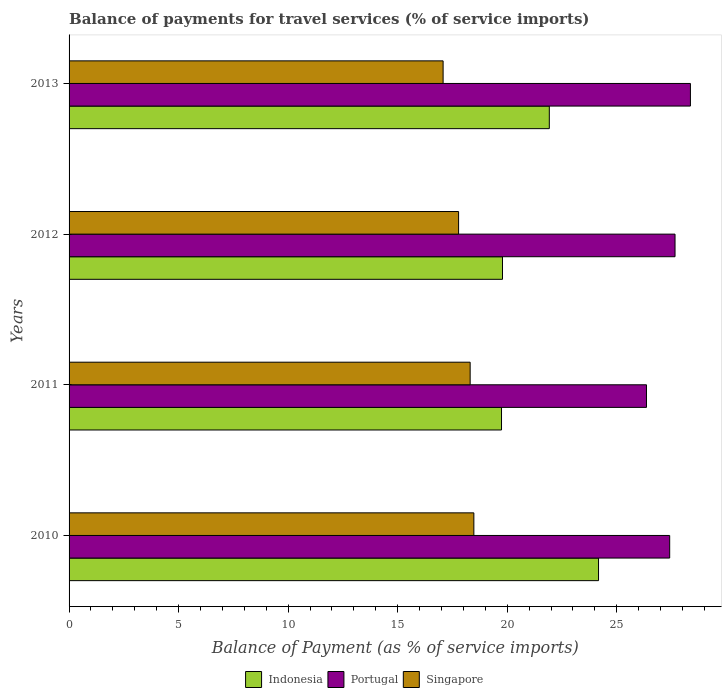How many different coloured bars are there?
Your answer should be compact. 3. Are the number of bars per tick equal to the number of legend labels?
Offer a terse response. Yes. Are the number of bars on each tick of the Y-axis equal?
Offer a terse response. Yes. In how many cases, is the number of bars for a given year not equal to the number of legend labels?
Offer a terse response. 0. What is the balance of payments for travel services in Singapore in 2012?
Provide a succinct answer. 17.78. Across all years, what is the maximum balance of payments for travel services in Portugal?
Give a very brief answer. 28.36. Across all years, what is the minimum balance of payments for travel services in Singapore?
Your answer should be very brief. 17.07. In which year was the balance of payments for travel services in Indonesia maximum?
Offer a very short reply. 2010. What is the total balance of payments for travel services in Indonesia in the graph?
Give a very brief answer. 85.61. What is the difference between the balance of payments for travel services in Indonesia in 2010 and that in 2013?
Provide a succinct answer. 2.25. What is the difference between the balance of payments for travel services in Singapore in 2010 and the balance of payments for travel services in Portugal in 2011?
Give a very brief answer. -7.88. What is the average balance of payments for travel services in Indonesia per year?
Your answer should be very brief. 21.4. In the year 2010, what is the difference between the balance of payments for travel services in Singapore and balance of payments for travel services in Portugal?
Offer a terse response. -8.94. In how many years, is the balance of payments for travel services in Indonesia greater than 1 %?
Offer a terse response. 4. What is the ratio of the balance of payments for travel services in Singapore in 2011 to that in 2012?
Make the answer very short. 1.03. What is the difference between the highest and the second highest balance of payments for travel services in Indonesia?
Keep it short and to the point. 2.25. What is the difference between the highest and the lowest balance of payments for travel services in Indonesia?
Your answer should be very brief. 4.43. What does the 3rd bar from the top in 2010 represents?
Offer a very short reply. Indonesia. Are all the bars in the graph horizontal?
Make the answer very short. Yes. How many years are there in the graph?
Offer a very short reply. 4. What is the difference between two consecutive major ticks on the X-axis?
Give a very brief answer. 5. Are the values on the major ticks of X-axis written in scientific E-notation?
Provide a short and direct response. No. Where does the legend appear in the graph?
Your answer should be very brief. Bottom center. How are the legend labels stacked?
Your answer should be very brief. Horizontal. What is the title of the graph?
Give a very brief answer. Balance of payments for travel services (% of service imports). What is the label or title of the X-axis?
Provide a short and direct response. Balance of Payment (as % of service imports). What is the Balance of Payment (as % of service imports) in Indonesia in 2010?
Offer a terse response. 24.17. What is the Balance of Payment (as % of service imports) in Portugal in 2010?
Provide a succinct answer. 27.41. What is the Balance of Payment (as % of service imports) in Singapore in 2010?
Your answer should be very brief. 18.48. What is the Balance of Payment (as % of service imports) of Indonesia in 2011?
Make the answer very short. 19.74. What is the Balance of Payment (as % of service imports) of Portugal in 2011?
Offer a terse response. 26.35. What is the Balance of Payment (as % of service imports) of Singapore in 2011?
Your answer should be compact. 18.31. What is the Balance of Payment (as % of service imports) of Indonesia in 2012?
Offer a very short reply. 19.78. What is the Balance of Payment (as % of service imports) of Portugal in 2012?
Offer a very short reply. 27.66. What is the Balance of Payment (as % of service imports) in Singapore in 2012?
Make the answer very short. 17.78. What is the Balance of Payment (as % of service imports) of Indonesia in 2013?
Give a very brief answer. 21.92. What is the Balance of Payment (as % of service imports) in Portugal in 2013?
Make the answer very short. 28.36. What is the Balance of Payment (as % of service imports) of Singapore in 2013?
Your response must be concise. 17.07. Across all years, what is the maximum Balance of Payment (as % of service imports) in Indonesia?
Provide a short and direct response. 24.17. Across all years, what is the maximum Balance of Payment (as % of service imports) in Portugal?
Keep it short and to the point. 28.36. Across all years, what is the maximum Balance of Payment (as % of service imports) of Singapore?
Your answer should be compact. 18.48. Across all years, what is the minimum Balance of Payment (as % of service imports) of Indonesia?
Ensure brevity in your answer.  19.74. Across all years, what is the minimum Balance of Payment (as % of service imports) of Portugal?
Keep it short and to the point. 26.35. Across all years, what is the minimum Balance of Payment (as % of service imports) of Singapore?
Offer a terse response. 17.07. What is the total Balance of Payment (as % of service imports) in Indonesia in the graph?
Give a very brief answer. 85.61. What is the total Balance of Payment (as % of service imports) in Portugal in the graph?
Provide a short and direct response. 109.79. What is the total Balance of Payment (as % of service imports) in Singapore in the graph?
Keep it short and to the point. 71.63. What is the difference between the Balance of Payment (as % of service imports) of Indonesia in 2010 and that in 2011?
Your response must be concise. 4.43. What is the difference between the Balance of Payment (as % of service imports) in Portugal in 2010 and that in 2011?
Offer a terse response. 1.06. What is the difference between the Balance of Payment (as % of service imports) of Singapore in 2010 and that in 2011?
Keep it short and to the point. 0.17. What is the difference between the Balance of Payment (as % of service imports) of Indonesia in 2010 and that in 2012?
Your response must be concise. 4.38. What is the difference between the Balance of Payment (as % of service imports) in Portugal in 2010 and that in 2012?
Make the answer very short. -0.24. What is the difference between the Balance of Payment (as % of service imports) of Singapore in 2010 and that in 2012?
Your answer should be compact. 0.7. What is the difference between the Balance of Payment (as % of service imports) of Indonesia in 2010 and that in 2013?
Give a very brief answer. 2.25. What is the difference between the Balance of Payment (as % of service imports) in Portugal in 2010 and that in 2013?
Offer a very short reply. -0.95. What is the difference between the Balance of Payment (as % of service imports) of Singapore in 2010 and that in 2013?
Your answer should be compact. 1.4. What is the difference between the Balance of Payment (as % of service imports) of Indonesia in 2011 and that in 2012?
Provide a short and direct response. -0.04. What is the difference between the Balance of Payment (as % of service imports) in Portugal in 2011 and that in 2012?
Offer a terse response. -1.3. What is the difference between the Balance of Payment (as % of service imports) of Singapore in 2011 and that in 2012?
Provide a short and direct response. 0.53. What is the difference between the Balance of Payment (as % of service imports) in Indonesia in 2011 and that in 2013?
Keep it short and to the point. -2.18. What is the difference between the Balance of Payment (as % of service imports) in Portugal in 2011 and that in 2013?
Your answer should be very brief. -2.01. What is the difference between the Balance of Payment (as % of service imports) in Singapore in 2011 and that in 2013?
Make the answer very short. 1.23. What is the difference between the Balance of Payment (as % of service imports) of Indonesia in 2012 and that in 2013?
Offer a very short reply. -2.14. What is the difference between the Balance of Payment (as % of service imports) of Portugal in 2012 and that in 2013?
Keep it short and to the point. -0.7. What is the difference between the Balance of Payment (as % of service imports) of Singapore in 2012 and that in 2013?
Your answer should be compact. 0.71. What is the difference between the Balance of Payment (as % of service imports) in Indonesia in 2010 and the Balance of Payment (as % of service imports) in Portugal in 2011?
Your response must be concise. -2.19. What is the difference between the Balance of Payment (as % of service imports) in Indonesia in 2010 and the Balance of Payment (as % of service imports) in Singapore in 2011?
Give a very brief answer. 5.86. What is the difference between the Balance of Payment (as % of service imports) of Portugal in 2010 and the Balance of Payment (as % of service imports) of Singapore in 2011?
Offer a terse response. 9.11. What is the difference between the Balance of Payment (as % of service imports) in Indonesia in 2010 and the Balance of Payment (as % of service imports) in Portugal in 2012?
Your answer should be compact. -3.49. What is the difference between the Balance of Payment (as % of service imports) of Indonesia in 2010 and the Balance of Payment (as % of service imports) of Singapore in 2012?
Your answer should be compact. 6.39. What is the difference between the Balance of Payment (as % of service imports) in Portugal in 2010 and the Balance of Payment (as % of service imports) in Singapore in 2012?
Provide a succinct answer. 9.63. What is the difference between the Balance of Payment (as % of service imports) in Indonesia in 2010 and the Balance of Payment (as % of service imports) in Portugal in 2013?
Provide a short and direct response. -4.19. What is the difference between the Balance of Payment (as % of service imports) of Indonesia in 2010 and the Balance of Payment (as % of service imports) of Singapore in 2013?
Offer a terse response. 7.09. What is the difference between the Balance of Payment (as % of service imports) of Portugal in 2010 and the Balance of Payment (as % of service imports) of Singapore in 2013?
Your answer should be very brief. 10.34. What is the difference between the Balance of Payment (as % of service imports) of Indonesia in 2011 and the Balance of Payment (as % of service imports) of Portugal in 2012?
Provide a short and direct response. -7.92. What is the difference between the Balance of Payment (as % of service imports) in Indonesia in 2011 and the Balance of Payment (as % of service imports) in Singapore in 2012?
Your response must be concise. 1.96. What is the difference between the Balance of Payment (as % of service imports) in Portugal in 2011 and the Balance of Payment (as % of service imports) in Singapore in 2012?
Your answer should be compact. 8.58. What is the difference between the Balance of Payment (as % of service imports) of Indonesia in 2011 and the Balance of Payment (as % of service imports) of Portugal in 2013?
Keep it short and to the point. -8.62. What is the difference between the Balance of Payment (as % of service imports) of Indonesia in 2011 and the Balance of Payment (as % of service imports) of Singapore in 2013?
Make the answer very short. 2.67. What is the difference between the Balance of Payment (as % of service imports) of Portugal in 2011 and the Balance of Payment (as % of service imports) of Singapore in 2013?
Ensure brevity in your answer.  9.28. What is the difference between the Balance of Payment (as % of service imports) of Indonesia in 2012 and the Balance of Payment (as % of service imports) of Portugal in 2013?
Your response must be concise. -8.58. What is the difference between the Balance of Payment (as % of service imports) of Indonesia in 2012 and the Balance of Payment (as % of service imports) of Singapore in 2013?
Provide a short and direct response. 2.71. What is the difference between the Balance of Payment (as % of service imports) of Portugal in 2012 and the Balance of Payment (as % of service imports) of Singapore in 2013?
Ensure brevity in your answer.  10.59. What is the average Balance of Payment (as % of service imports) of Indonesia per year?
Provide a succinct answer. 21.4. What is the average Balance of Payment (as % of service imports) of Portugal per year?
Offer a terse response. 27.45. What is the average Balance of Payment (as % of service imports) in Singapore per year?
Your response must be concise. 17.91. In the year 2010, what is the difference between the Balance of Payment (as % of service imports) of Indonesia and Balance of Payment (as % of service imports) of Portugal?
Your answer should be very brief. -3.25. In the year 2010, what is the difference between the Balance of Payment (as % of service imports) in Indonesia and Balance of Payment (as % of service imports) in Singapore?
Your response must be concise. 5.69. In the year 2010, what is the difference between the Balance of Payment (as % of service imports) of Portugal and Balance of Payment (as % of service imports) of Singapore?
Keep it short and to the point. 8.94. In the year 2011, what is the difference between the Balance of Payment (as % of service imports) of Indonesia and Balance of Payment (as % of service imports) of Portugal?
Ensure brevity in your answer.  -6.62. In the year 2011, what is the difference between the Balance of Payment (as % of service imports) in Indonesia and Balance of Payment (as % of service imports) in Singapore?
Offer a very short reply. 1.43. In the year 2011, what is the difference between the Balance of Payment (as % of service imports) in Portugal and Balance of Payment (as % of service imports) in Singapore?
Provide a succinct answer. 8.05. In the year 2012, what is the difference between the Balance of Payment (as % of service imports) of Indonesia and Balance of Payment (as % of service imports) of Portugal?
Give a very brief answer. -7.87. In the year 2012, what is the difference between the Balance of Payment (as % of service imports) of Indonesia and Balance of Payment (as % of service imports) of Singapore?
Make the answer very short. 2. In the year 2012, what is the difference between the Balance of Payment (as % of service imports) of Portugal and Balance of Payment (as % of service imports) of Singapore?
Make the answer very short. 9.88. In the year 2013, what is the difference between the Balance of Payment (as % of service imports) in Indonesia and Balance of Payment (as % of service imports) in Portugal?
Make the answer very short. -6.44. In the year 2013, what is the difference between the Balance of Payment (as % of service imports) of Indonesia and Balance of Payment (as % of service imports) of Singapore?
Your answer should be very brief. 4.85. In the year 2013, what is the difference between the Balance of Payment (as % of service imports) in Portugal and Balance of Payment (as % of service imports) in Singapore?
Provide a short and direct response. 11.29. What is the ratio of the Balance of Payment (as % of service imports) of Indonesia in 2010 to that in 2011?
Offer a very short reply. 1.22. What is the ratio of the Balance of Payment (as % of service imports) in Portugal in 2010 to that in 2011?
Keep it short and to the point. 1.04. What is the ratio of the Balance of Payment (as % of service imports) of Singapore in 2010 to that in 2011?
Provide a short and direct response. 1.01. What is the ratio of the Balance of Payment (as % of service imports) in Indonesia in 2010 to that in 2012?
Ensure brevity in your answer.  1.22. What is the ratio of the Balance of Payment (as % of service imports) in Singapore in 2010 to that in 2012?
Keep it short and to the point. 1.04. What is the ratio of the Balance of Payment (as % of service imports) in Indonesia in 2010 to that in 2013?
Ensure brevity in your answer.  1.1. What is the ratio of the Balance of Payment (as % of service imports) of Portugal in 2010 to that in 2013?
Give a very brief answer. 0.97. What is the ratio of the Balance of Payment (as % of service imports) in Singapore in 2010 to that in 2013?
Give a very brief answer. 1.08. What is the ratio of the Balance of Payment (as % of service imports) in Indonesia in 2011 to that in 2012?
Offer a terse response. 1. What is the ratio of the Balance of Payment (as % of service imports) of Portugal in 2011 to that in 2012?
Ensure brevity in your answer.  0.95. What is the ratio of the Balance of Payment (as % of service imports) in Singapore in 2011 to that in 2012?
Make the answer very short. 1.03. What is the ratio of the Balance of Payment (as % of service imports) of Indonesia in 2011 to that in 2013?
Offer a terse response. 0.9. What is the ratio of the Balance of Payment (as % of service imports) in Portugal in 2011 to that in 2013?
Offer a very short reply. 0.93. What is the ratio of the Balance of Payment (as % of service imports) of Singapore in 2011 to that in 2013?
Your answer should be compact. 1.07. What is the ratio of the Balance of Payment (as % of service imports) in Indonesia in 2012 to that in 2013?
Ensure brevity in your answer.  0.9. What is the ratio of the Balance of Payment (as % of service imports) of Portugal in 2012 to that in 2013?
Your answer should be compact. 0.98. What is the ratio of the Balance of Payment (as % of service imports) in Singapore in 2012 to that in 2013?
Your response must be concise. 1.04. What is the difference between the highest and the second highest Balance of Payment (as % of service imports) of Indonesia?
Ensure brevity in your answer.  2.25. What is the difference between the highest and the second highest Balance of Payment (as % of service imports) of Portugal?
Offer a terse response. 0.7. What is the difference between the highest and the second highest Balance of Payment (as % of service imports) in Singapore?
Give a very brief answer. 0.17. What is the difference between the highest and the lowest Balance of Payment (as % of service imports) of Indonesia?
Your answer should be compact. 4.43. What is the difference between the highest and the lowest Balance of Payment (as % of service imports) in Portugal?
Offer a terse response. 2.01. What is the difference between the highest and the lowest Balance of Payment (as % of service imports) in Singapore?
Give a very brief answer. 1.4. 